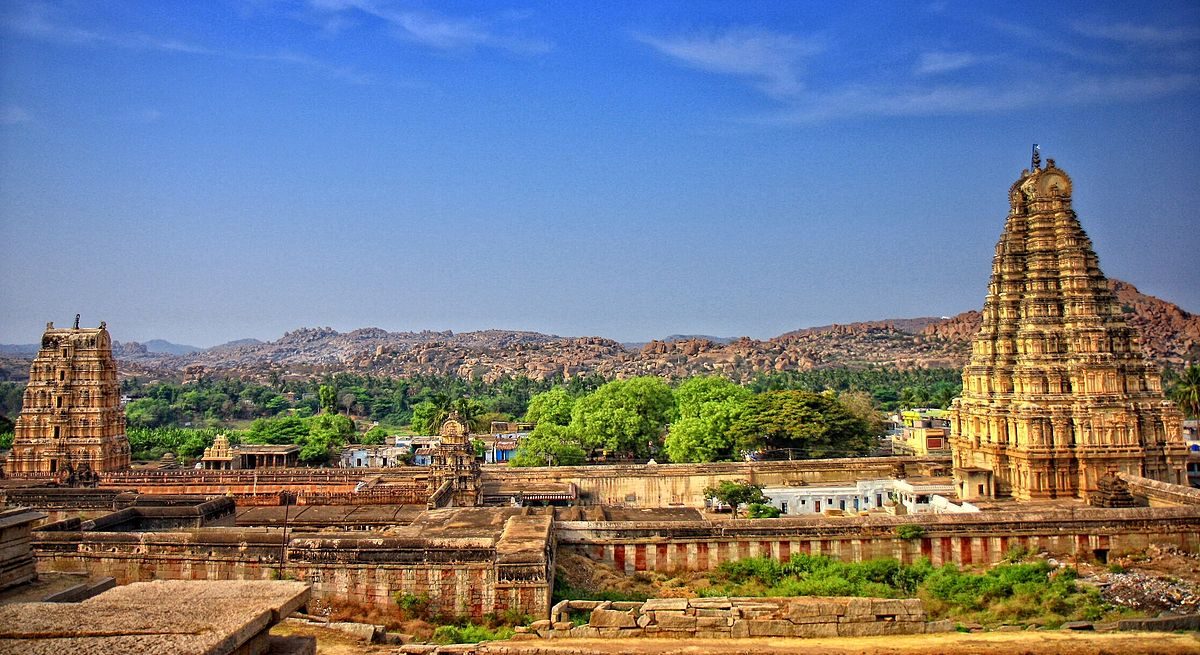Write a detailed description of the given image. The image presents an expansive view of the Virupaksha Temple, located in the UNESCO World Heritage Site of Hampi, India. This temple, dedicated to Lord Shiva, is a centerpiece of the ancient city, which was once the capital of the Vijayanagara Empire. The photo is shot from an elevated viewpoint, showcasing the temple’s impressive gopurams (tower-like structures) adorned with intricate religious sculptures that tell tales from Hindu mythology.

The temple's ancient stone architecture is set against a vivid blue sky, and the surrounding landscape of boulder-strewn hills creates a striking natural backdrop. The foreground shows a series of smaller ruins and temple structures, indicating the large scale of this religious complex. This temple is not just an architectural marvel but also a living cultural site where daily rituals and annual festivals bring together a vibrant community of devotees. The consumption of this image, enriched with both natural beauty and spiritual resonance, offers a glimpse into India’s rich past and its continuing traditions. 